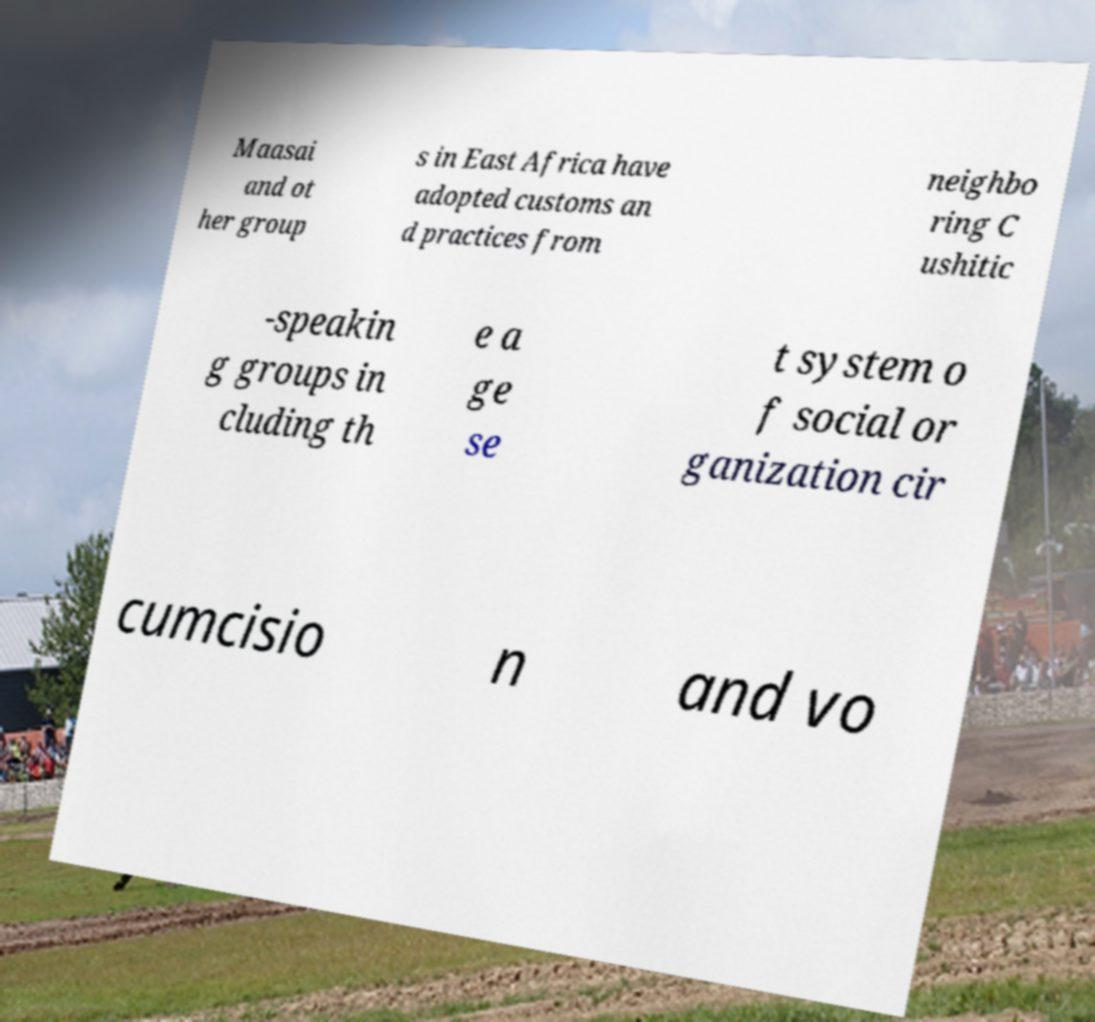Can you read and provide the text displayed in the image?This photo seems to have some interesting text. Can you extract and type it out for me? Maasai and ot her group s in East Africa have adopted customs an d practices from neighbo ring C ushitic -speakin g groups in cluding th e a ge se t system o f social or ganization cir cumcisio n and vo 